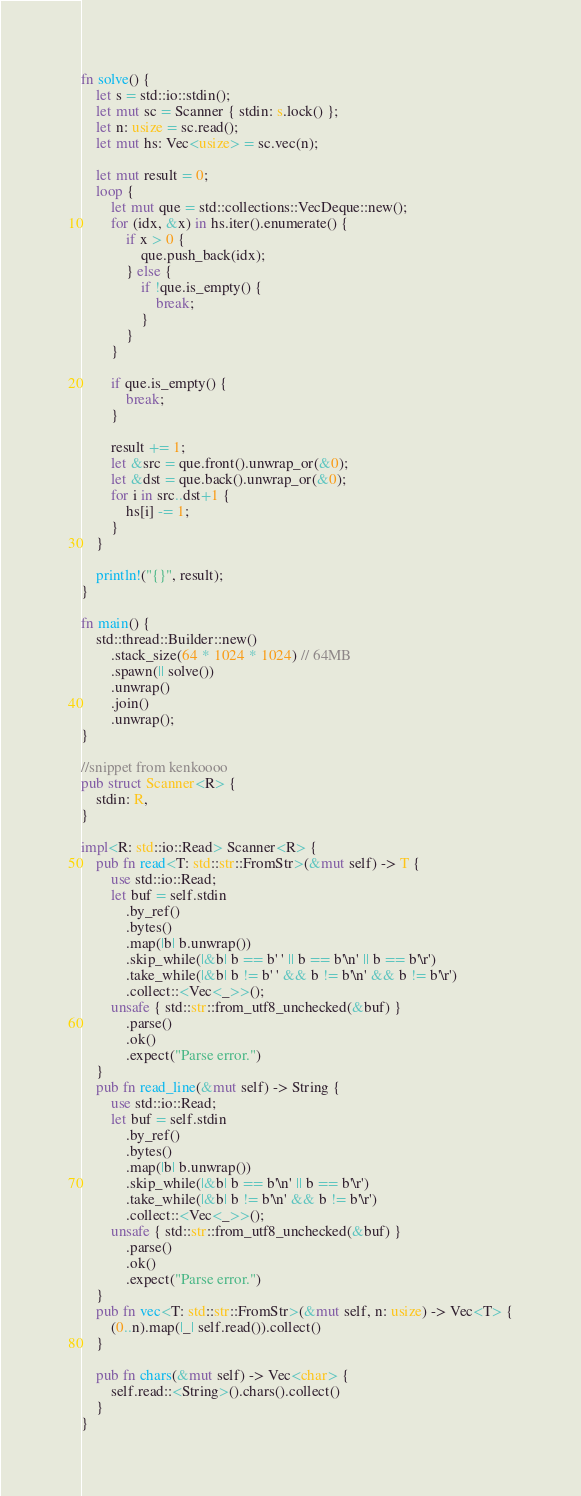Convert code to text. <code><loc_0><loc_0><loc_500><loc_500><_Rust_>fn solve() {
    let s = std::io::stdin();
    let mut sc = Scanner { stdin: s.lock() };
    let n: usize = sc.read();
    let mut hs: Vec<usize> = sc.vec(n);

    let mut result = 0;
    loop {
        let mut que = std::collections::VecDeque::new();
        for (idx, &x) in hs.iter().enumerate() {
            if x > 0 {
                que.push_back(idx);
            } else {
                if !que.is_empty() {
                    break;
                }
            }
        }

        if que.is_empty() {
            break;
        }

        result += 1;
        let &src = que.front().unwrap_or(&0);
        let &dst = que.back().unwrap_or(&0);
        for i in src..dst+1 {
            hs[i] -= 1;
        }
    }

    println!("{}", result);
}

fn main() {
    std::thread::Builder::new()
        .stack_size(64 * 1024 * 1024) // 64MB
        .spawn(|| solve())
        .unwrap()
        .join()
        .unwrap();
}

//snippet from kenkoooo
pub struct Scanner<R> {
    stdin: R,
}

impl<R: std::io::Read> Scanner<R> {
    pub fn read<T: std::str::FromStr>(&mut self) -> T {
        use std::io::Read;
        let buf = self.stdin
            .by_ref()
            .bytes()
            .map(|b| b.unwrap())
            .skip_while(|&b| b == b' ' || b == b'\n' || b == b'\r')
            .take_while(|&b| b != b' ' && b != b'\n' && b != b'\r')
            .collect::<Vec<_>>();
        unsafe { std::str::from_utf8_unchecked(&buf) }
            .parse()
            .ok()
            .expect("Parse error.")
    }
    pub fn read_line(&mut self) -> String {
        use std::io::Read;
        let buf = self.stdin
            .by_ref()
            .bytes()
            .map(|b| b.unwrap())
            .skip_while(|&b| b == b'\n' || b == b'\r')
            .take_while(|&b| b != b'\n' && b != b'\r')
            .collect::<Vec<_>>();
        unsafe { std::str::from_utf8_unchecked(&buf) }
            .parse()
            .ok()
            .expect("Parse error.")
    }
    pub fn vec<T: std::str::FromStr>(&mut self, n: usize) -> Vec<T> {
        (0..n).map(|_| self.read()).collect()
    }

    pub fn chars(&mut self) -> Vec<char> {
        self.read::<String>().chars().collect()
    }
}

</code> 